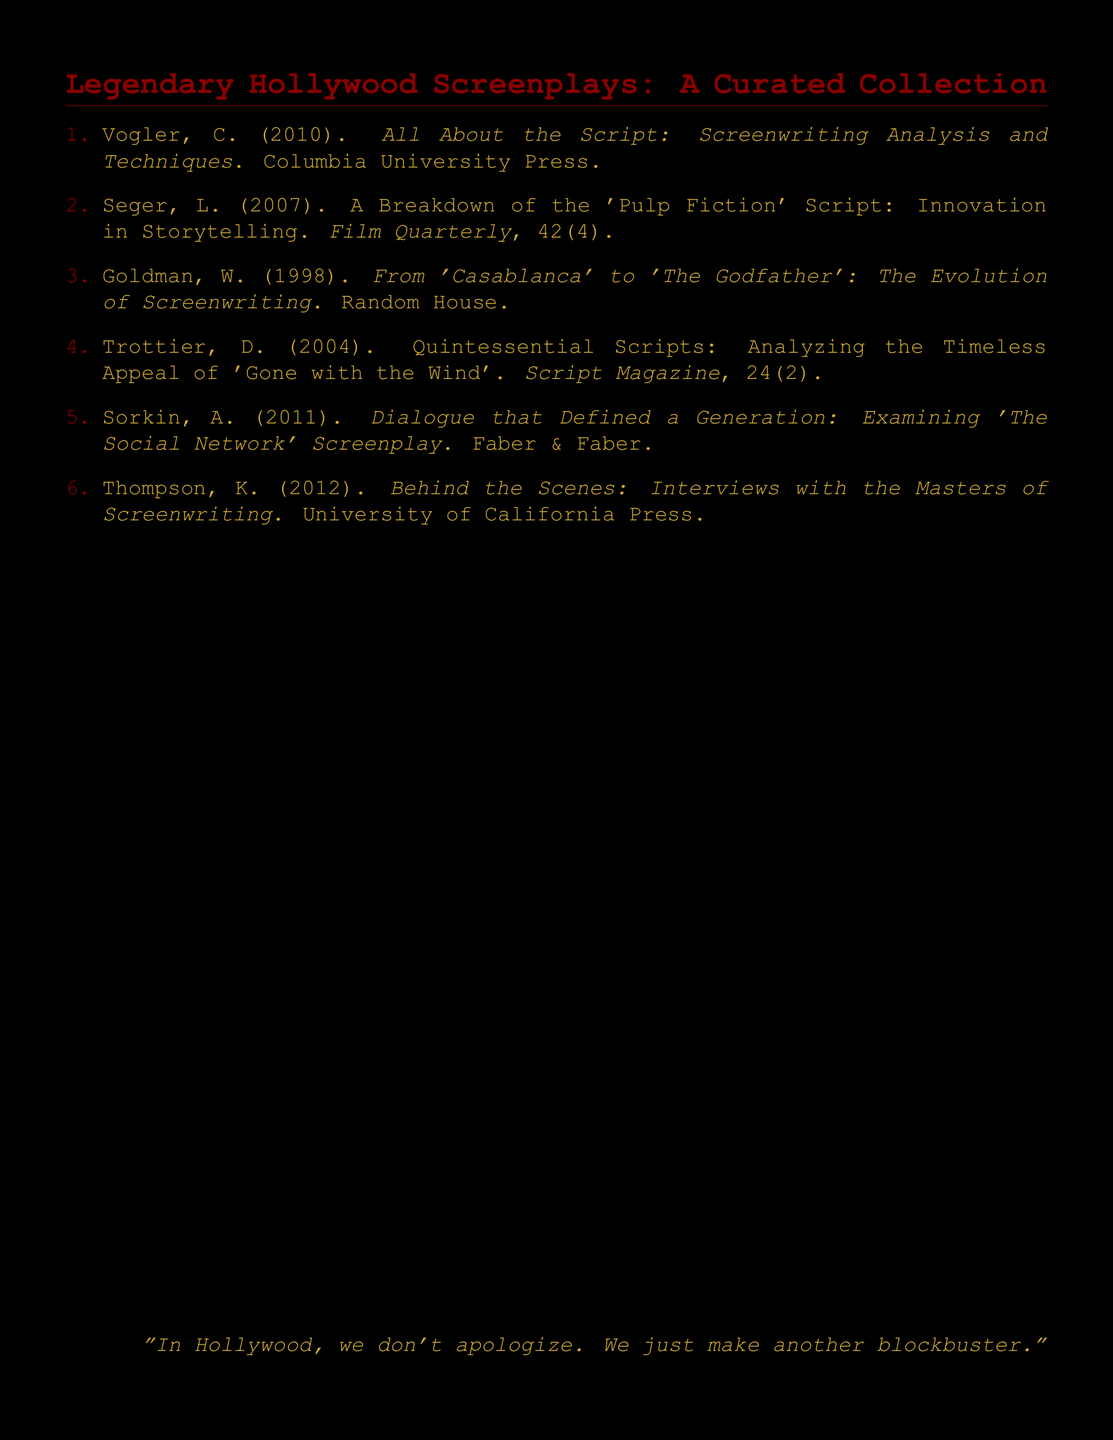What is the first author's name in the bibliography? The first author listed in the bibliography is Christopher Vogler.
Answer: Christopher Vogler What year was "All About the Script: Screenwriting Analysis and Techniques" published? The publication year for this work is 2010.
Answer: 2010 How many items are in the bibliography? The document lists six items in total.
Answer: 6 What is the title of the paper by Linda Seger? The title of the paper focuses on a breakdown of the 'Pulp Fiction' script.
Answer: A Breakdown of the 'Pulp Fiction' Script: Innovation in Storytelling Who published the work analyzing 'The Social Network' screenplay? The analysis of 'The Social Network' screenplay was published by Faber & Faber.
Answer: Faber & Faber What quote appears at the bottom of the document? The quote emphasizes Hollywood's approach to public relations regarding failures.
Answer: "In Hollywood, we don't apologize. We just make another blockbuster." 